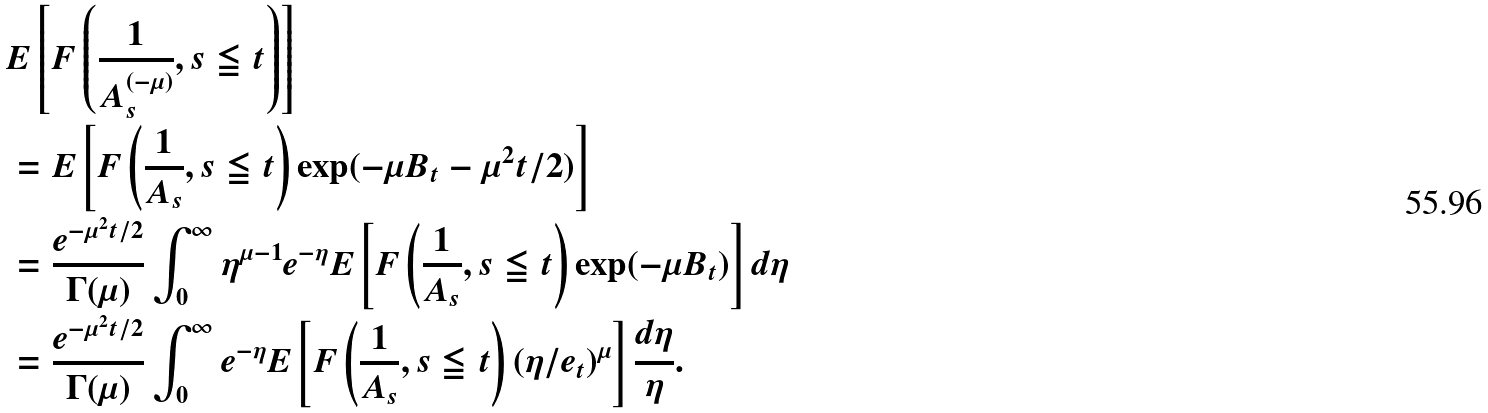Convert formula to latex. <formula><loc_0><loc_0><loc_500><loc_500>& E \left [ F \left ( \frac { 1 } { A _ { s } ^ { ( - \mu ) } } , s \leqq t \right ) \right ] \\ & = E \left [ F \left ( \frac { 1 } { A _ { s } } , s \leqq t \right ) \exp ( - \mu B _ { t } - \mu ^ { 2 } t / 2 ) \right ] \\ & = \frac { e ^ { - \mu ^ { 2 } t / 2 } } { \Gamma ( \mu ) } \int _ { 0 } ^ { \infty } \eta ^ { \mu - 1 } e ^ { - \eta } E \left [ F \left ( \frac { 1 } { A _ { s } } , s \leqq t \right ) \exp ( - \mu B _ { t } ) \right ] d \eta \\ & = \frac { e ^ { - \mu ^ { 2 } t / 2 } } { \Gamma ( \mu ) } \int _ { 0 } ^ { \infty } e ^ { - \eta } E \left [ F \left ( \frac { 1 } { A _ { s } } , s \leqq t \right ) ( \eta / e _ { t } ) ^ { \mu } \right ] \frac { d \eta } { \eta } .</formula> 